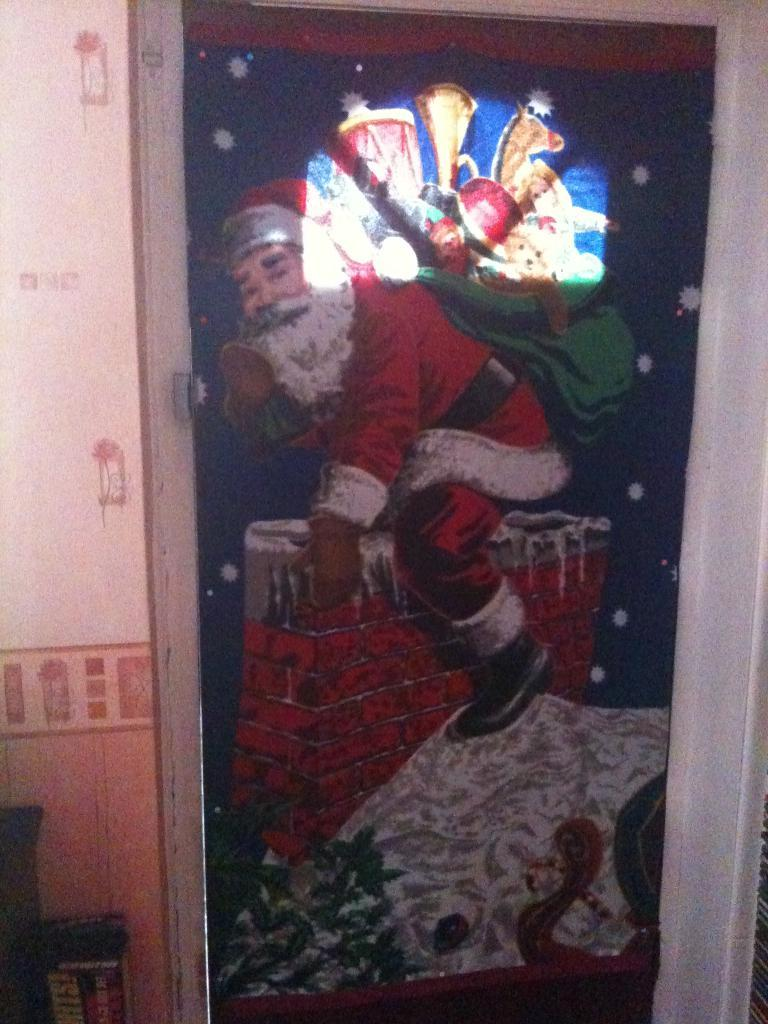What is present on the wall in the image? There is a door on the wall in the image. What is depicted on the door? There is a painting of Santa Claus on the door. What type of discovery was made by the substance on the door? There is no substance present on the door, and therefore no discovery can be made. 